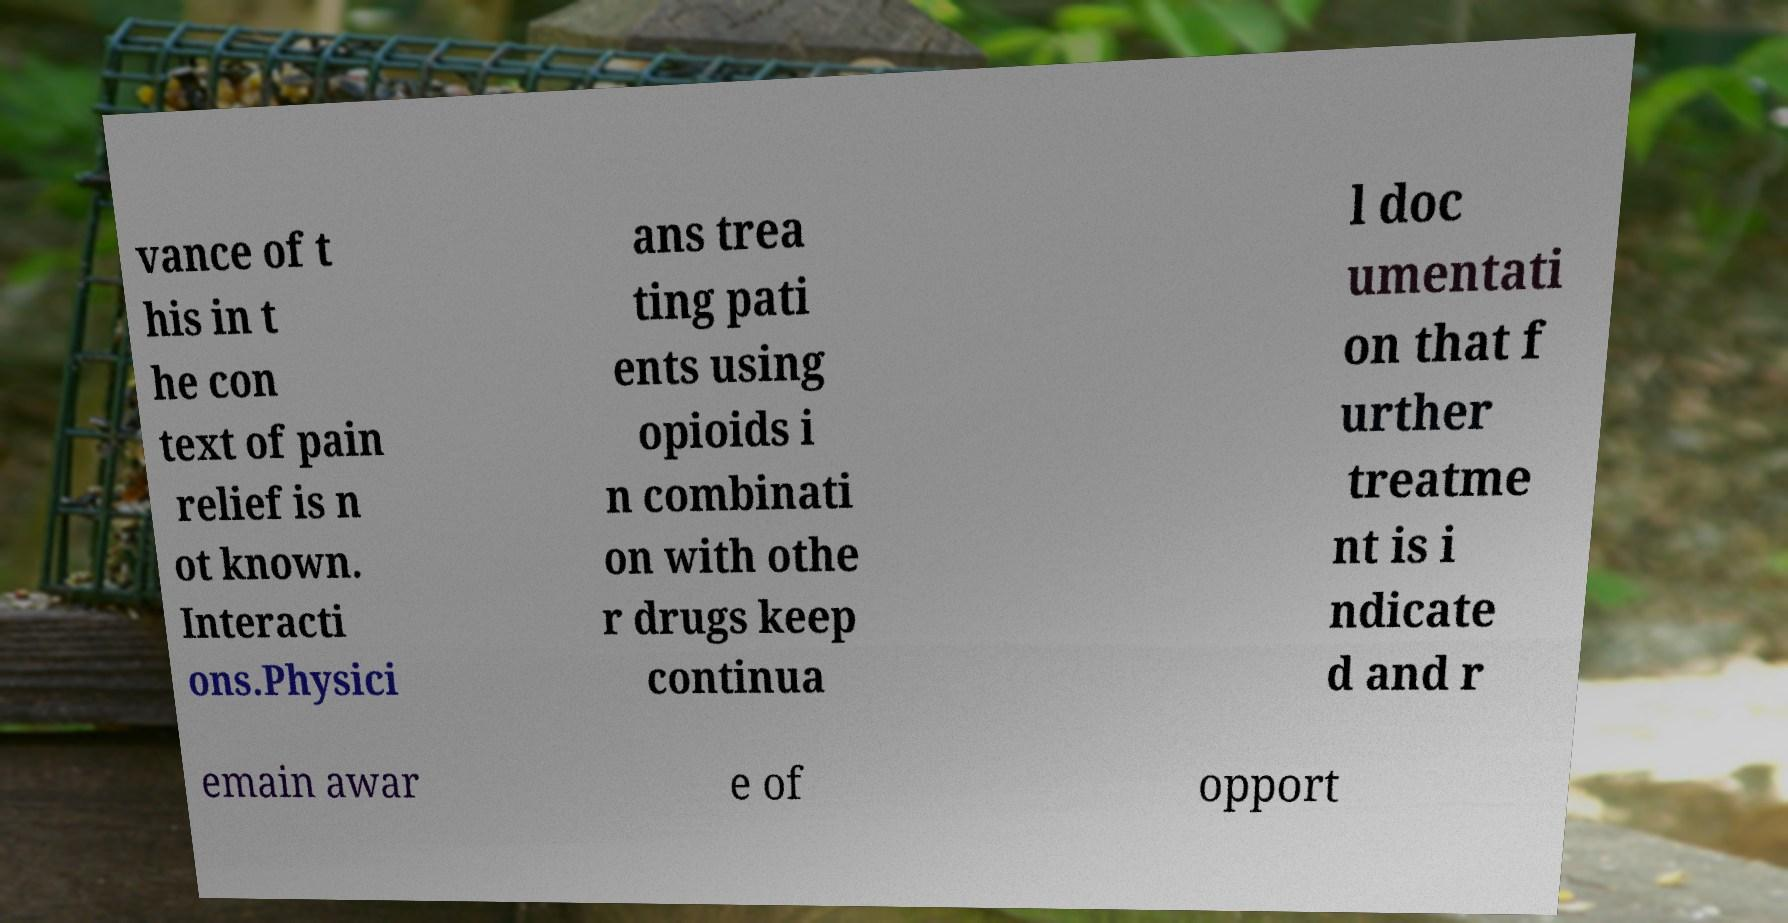What messages or text are displayed in this image? I need them in a readable, typed format. vance of t his in t he con text of pain relief is n ot known. Interacti ons.Physici ans trea ting pati ents using opioids i n combinati on with othe r drugs keep continua l doc umentati on that f urther treatme nt is i ndicate d and r emain awar e of opport 